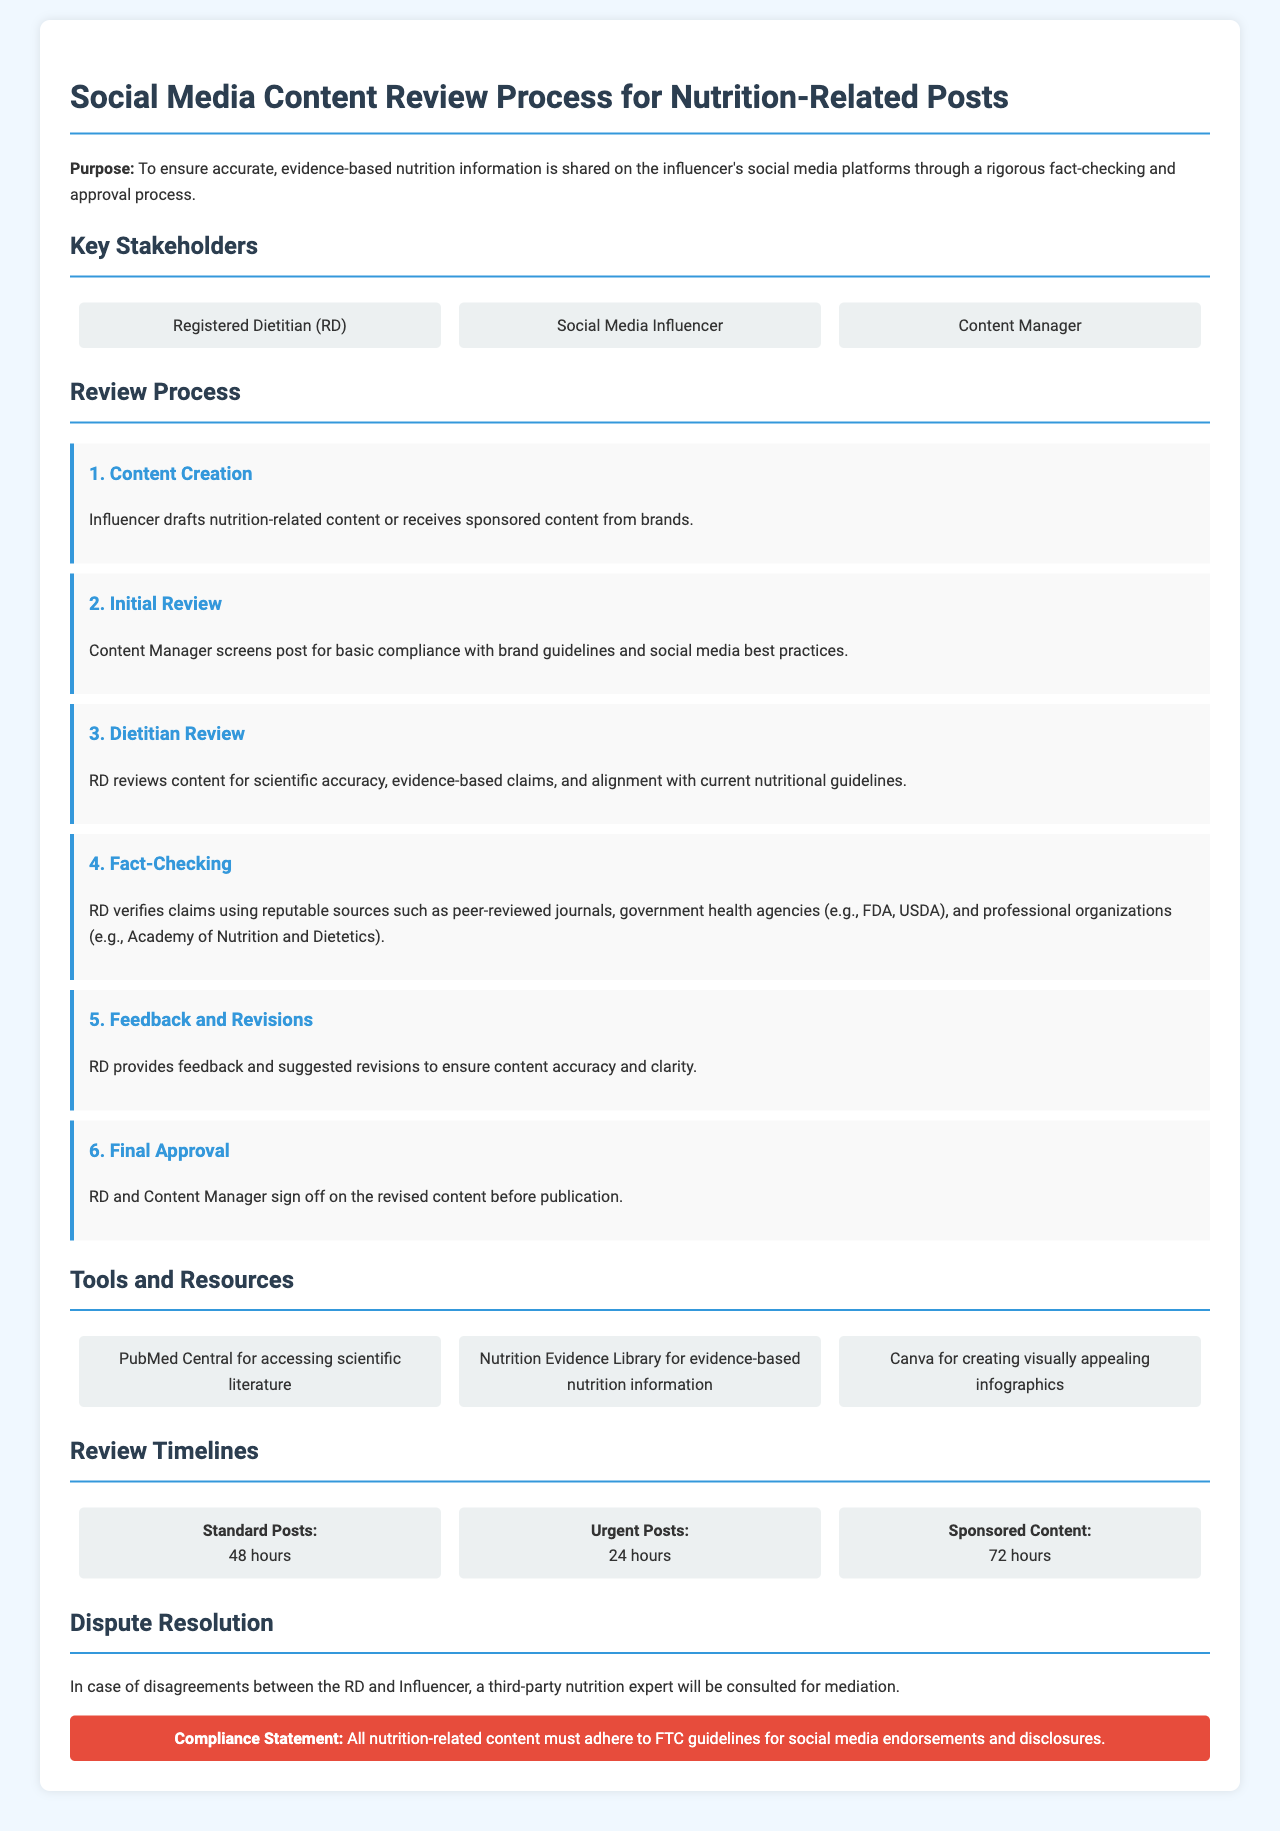What is the purpose of the document? The purpose outlines the intention to ensure accurate, evidence-based nutrition information is shared through a rigorous fact-checking and approval process.
Answer: To ensure accurate, evidence-based nutrition information is shared Who reviews the content for scientific accuracy? The review process specifies that the Registered Dietitian is responsible for reviewing content for scientific accuracy and evidence-based claims.
Answer: Registered Dietitian (RD) What is the review timeline for standard posts? The document lists review timelines, stating that standard posts require 48 hours for review.
Answer: 48 hours Which tool is used for accessing scientific literature? The tools section includes PubMed Central as the resource used for accessing scientific literature.
Answer: PubMed Central What happens in case of disagreements? The document describes that a third-party nutrition expert will be consulted for mediation in the event of disagreements.
Answer: Third-party nutrition expert How many stakeholders are involved in the review process? The key stakeholders section lists three individuals involved in the review process: Registered Dietitian, Social Media Influencer, and Content Manager.
Answer: Three What type of posts requires the longest review time? The review timelines indicate that sponsored content requires the longest review time of 72 hours.
Answer: 72 hours What compliance statement is mentioned in the document? The compliance section mandates that all content must adhere to FTC guidelines for social media endorsements and disclosures.
Answer: FTC guidelines for social media endorsements and disclosures 